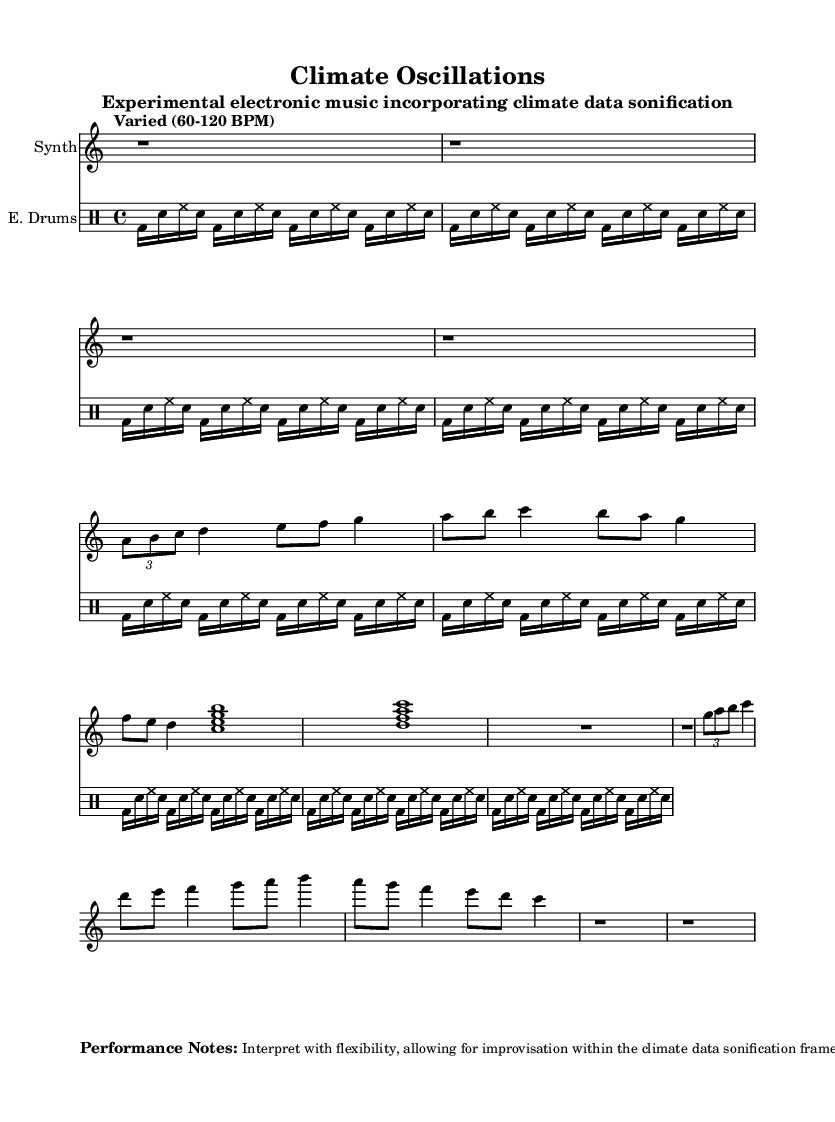What is the time signature of this music? The time signature is shown at the beginning of the piece as 4/4, indicating four beats per measure.
Answer: 4/4 What is the tempo range indicated in the score? The tempo is described as "Varied (60-120 BPM)," which informs the performer to play within that beats per minute range.
Answer: Varied (60-120 BPM) What section represents temperature anomaly data? Section A is indicated explicitly as "Section A (Temperature anomaly data representation)" in the score.
Answer: Section A How many measures are in the Synthesizer part? The Synthesizer part consists of multiple sections, including sections A, B, A', and an intro/outro, totaling approximately 9 measures.
Answer: 9 What rhythmic pattern is used in the drums part? The drums part features a repeated 16th note pattern consisting of bass drum, snare, and hi-hat, reflected in the drum notation.
Answer: 16th note pattern What do the performance notes suggest for interpretation? The performance notes highlight flexibility and improvisation within the climate data sonification framework.
Answer: Flexibility, improvisation What instrument is primarily featured in the score? The primary instrument is indicated as "Synth" in the staff name.
Answer: Synth 